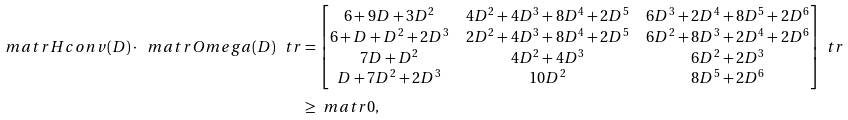Convert formula to latex. <formula><loc_0><loc_0><loc_500><loc_500>\ m a t r H c o n v ( D ) \cdot \ m a t r O m e g a ( D ) ^ { \ } t r & = \begin{bmatrix} 6 + 9 D + 3 D ^ { 2 } & 4 D ^ { 2 } + 4 D ^ { 3 } + 8 D ^ { 4 } + 2 D ^ { 5 } & 6 D ^ { 3 } + 2 D ^ { 4 } + 8 D ^ { 5 } + 2 D ^ { 6 } \\ 6 + D + D ^ { 2 } + 2 D ^ { 3 } & 2 D ^ { 2 } + 4 D ^ { 3 } + 8 D ^ { 4 } + 2 D ^ { 5 } & 6 D ^ { 2 } + 8 D ^ { 3 } + 2 D ^ { 4 } + 2 D ^ { 6 } \\ 7 D + D ^ { 2 } & 4 D ^ { 2 } + 4 D ^ { 3 } & 6 D ^ { 2 } + 2 D ^ { 3 } \\ D + 7 D ^ { 2 } + 2 D ^ { 3 } & 1 0 D ^ { 2 } & 8 D ^ { 5 } + 2 D ^ { 6 } \end{bmatrix} ^ { \ } t r \\ & \geq \ m a t r { 0 } ,</formula> 